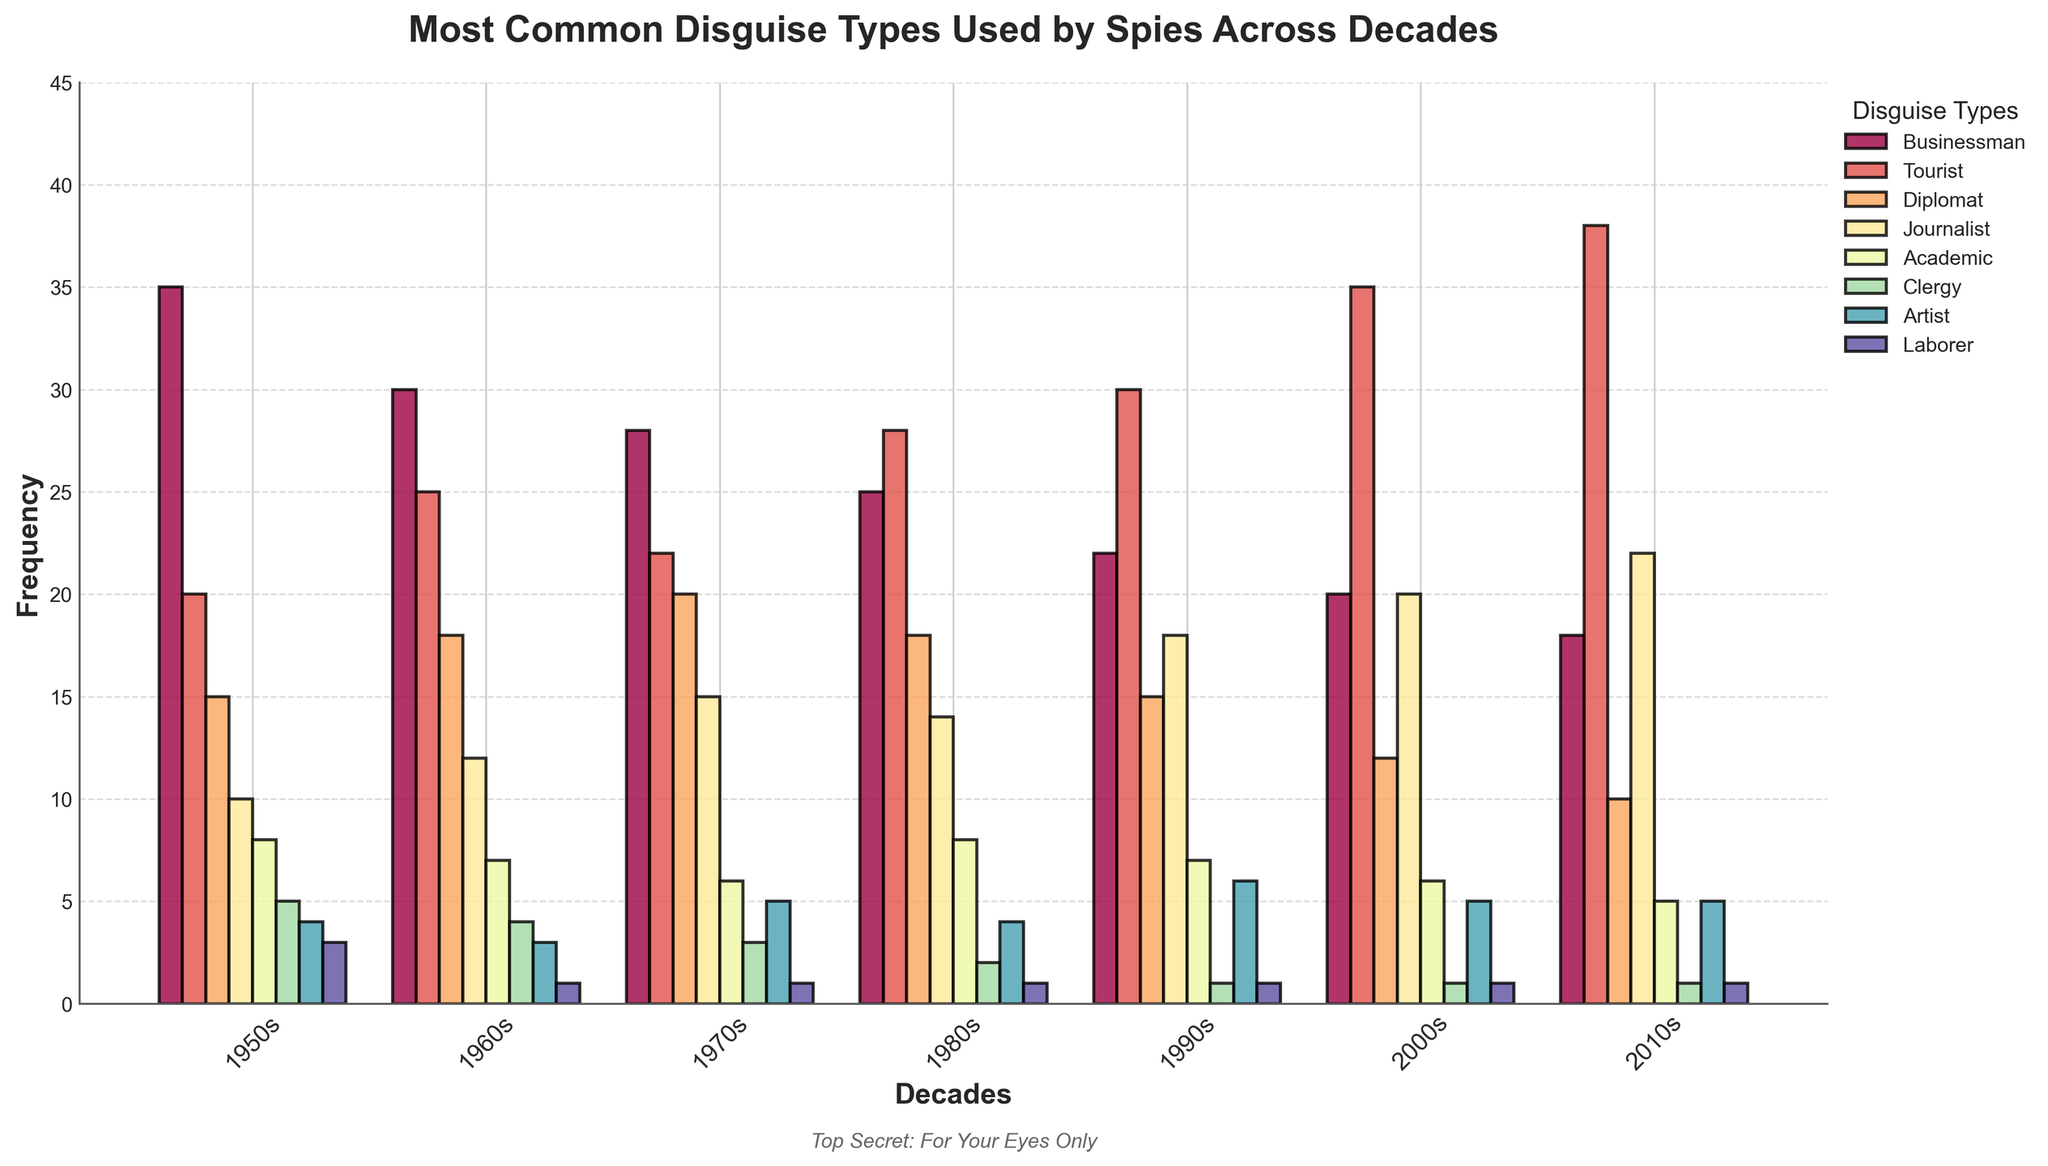which disguise type increased the most between the 1950s and 2010s? By comparing each disguise type's frequency in the 1950s and the 2010s, we notice that the 'Tourist' disguise increased from 20 in the 1950s to 38 in the 2010s, giving it the highest increase of 18.
Answer: Tourist how many times was the artist disguise used in the total six decades listed? By summing the artist disguises over all decades (1950s: 4, 1960s: 3, 1970s: 5, 1980s: 4, 1990s: 6, 2000s: 5, 2010s: 5), the total usage is 4+3+5+4+6+5+5 = 32.
Answer: 32 which disguise saw the greatest decrease from the 1950s to 2010s? By comparing each disguise type from the 1950s to the 2010s, the Businessman disguise decreased from 35 in the 1950s to 18 in the 2010s, a decrease of 17, which is the greatest.
Answer: Businessman which disguise type had the highest frequency of use in the 1980s? In the 1980s, the Tourist disguise had the highest frequency of use at 28.
Answer: Tourist considering all decades, which two disguise types appear the least frequently? Summing up the usage counts for all decades for each disguise type, the Laborer and Clergy disguises appear the least frequently, each totaling 8 appearances.
Answer: Laborer and Clergy which decade shows the highest combined usage of Diplomat and Journalist disguises? To determine this, we sum the Diplomat and Journalist values for each decade and compare. The 2010s have the largest combined use with Diplomat (10) + Journalist (22) = 32.
Answer: 2010s what is the percentage change in usage of the Journalist disguise from the 1950s to the 2000s? The usage of Journalist disguises increased from 10 in the 1950s to 20 in the 2000s. The percentage change is ((20-10)/10) * 100% = 100%.
Answer: 100% in which decade did the academic disguise see the least use? By comparing the usage of the Academic disguise in each decade, the 2010s had the fewest with 5 occurrences.
Answer: 2010s how many total disguise types were used more than 20 times in the 1960s? In the 1960s, the disguise types used more than 20 times were Tourist (25), Diplomat (18), and Businessman (30), so there are 3 types in total.
Answer: 3 comparing the use of the laborer disguise in the 1950s to the 2010s, has its frequency increased, decreased, or remained the same? In both the 1950s and the 2010s, the Laborer disguise was used 1 time, so its frequency has remained the same.
Answer: Remained the same 